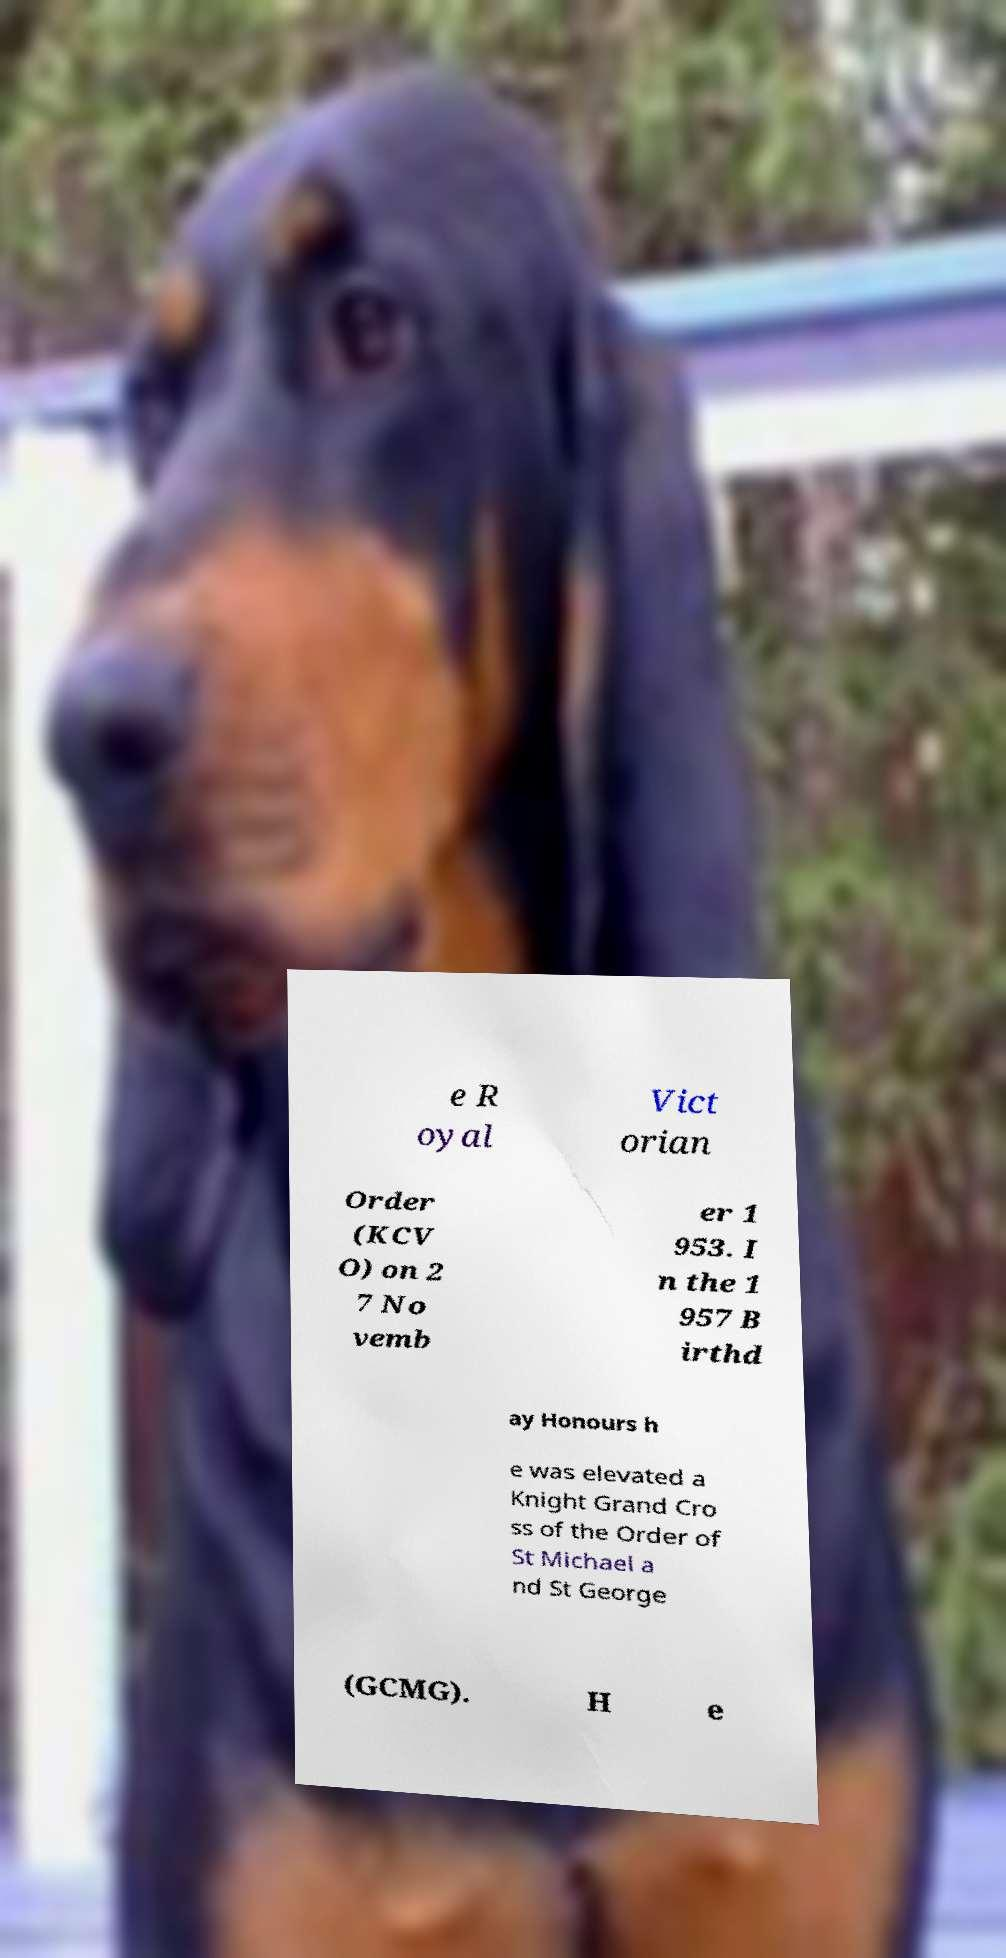I need the written content from this picture converted into text. Can you do that? e R oyal Vict orian Order (KCV O) on 2 7 No vemb er 1 953. I n the 1 957 B irthd ay Honours h e was elevated a Knight Grand Cro ss of the Order of St Michael a nd St George (GCMG). H e 